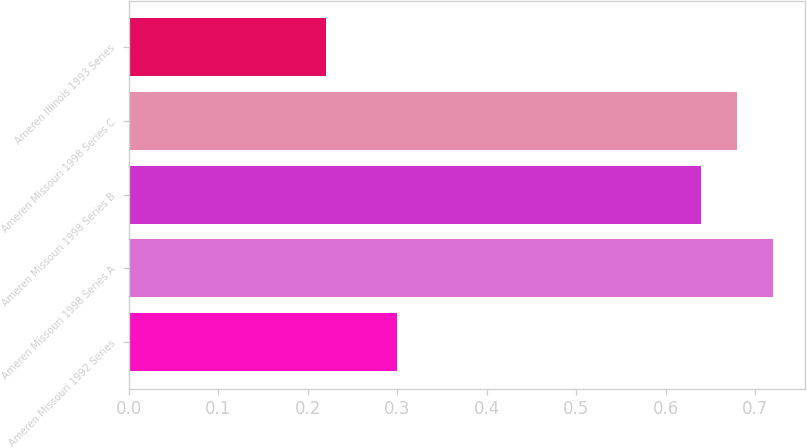Convert chart to OTSL. <chart><loc_0><loc_0><loc_500><loc_500><bar_chart><fcel>Ameren Missouri 1992 Series<fcel>Ameren Missouri 1998 Series A<fcel>Ameren Missouri 1998 Series B<fcel>Ameren Missouri 1998 Series C<fcel>Ameren Illinois 1993 Series<nl><fcel>0.3<fcel>0.72<fcel>0.64<fcel>0.68<fcel>0.22<nl></chart> 